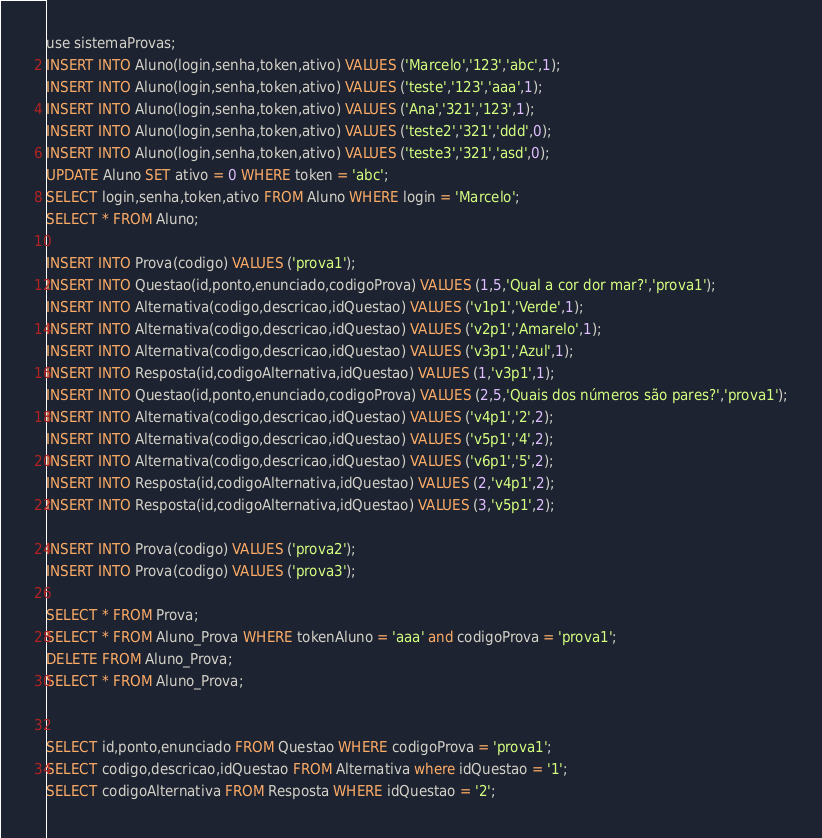Convert code to text. <code><loc_0><loc_0><loc_500><loc_500><_SQL_>use sistemaProvas;
INSERT INTO Aluno(login,senha,token,ativo) VALUES ('Marcelo','123','abc',1);
INSERT INTO Aluno(login,senha,token,ativo) VALUES ('teste','123','aaa',1);
INSERT INTO Aluno(login,senha,token,ativo) VALUES ('Ana','321','123',1);
INSERT INTO Aluno(login,senha,token,ativo) VALUES ('teste2','321','ddd',0);
INSERT INTO Aluno(login,senha,token,ativo) VALUES ('teste3','321','asd',0);
UPDATE Aluno SET ativo = 0 WHERE token = 'abc'; 
SELECT login,senha,token,ativo FROM Aluno WHERE login = 'Marcelo';
SELECT * FROM Aluno;

INSERT INTO Prova(codigo) VALUES ('prova1');
INSERT INTO Questao(id,ponto,enunciado,codigoProva) VALUES (1,5,'Qual a cor dor mar?','prova1');
INSERT INTO Alternativa(codigo,descricao,idQuestao) VALUES ('v1p1','Verde',1);
INSERT INTO Alternativa(codigo,descricao,idQuestao) VALUES ('v2p1','Amarelo',1);
INSERT INTO Alternativa(codigo,descricao,idQuestao) VALUES ('v3p1','Azul',1);
INSERT INTO Resposta(id,codigoAlternativa,idQuestao) VALUES (1,'v3p1',1);
INSERT INTO Questao(id,ponto,enunciado,codigoProva) VALUES (2,5,'Quais dos números são pares?','prova1');
INSERT INTO Alternativa(codigo,descricao,idQuestao) VALUES ('v4p1','2',2);
INSERT INTO Alternativa(codigo,descricao,idQuestao) VALUES ('v5p1','4',2);
INSERT INTO Alternativa(codigo,descricao,idQuestao) VALUES ('v6p1','5',2);
INSERT INTO Resposta(id,codigoAlternativa,idQuestao) VALUES (2,'v4p1',2);
INSERT INTO Resposta(id,codigoAlternativa,idQuestao) VALUES (3,'v5p1',2);

INSERT INTO Prova(codigo) VALUES ('prova2');
INSERT INTO Prova(codigo) VALUES ('prova3');

SELECT * FROM Prova;
SELECT * FROM Aluno_Prova WHERE tokenAluno = 'aaa' and codigoProva = 'prova1';
DELETE FROM Aluno_Prova;
SELECT * FROM Aluno_Prova;


SELECT id,ponto,enunciado FROM Questao WHERE codigoProva = 'prova1';
SELECT codigo,descricao,idQuestao FROM Alternativa where idQuestao = '1';
SELECT codigoAlternativa FROM Resposta WHERE idQuestao = '2';
</code> 